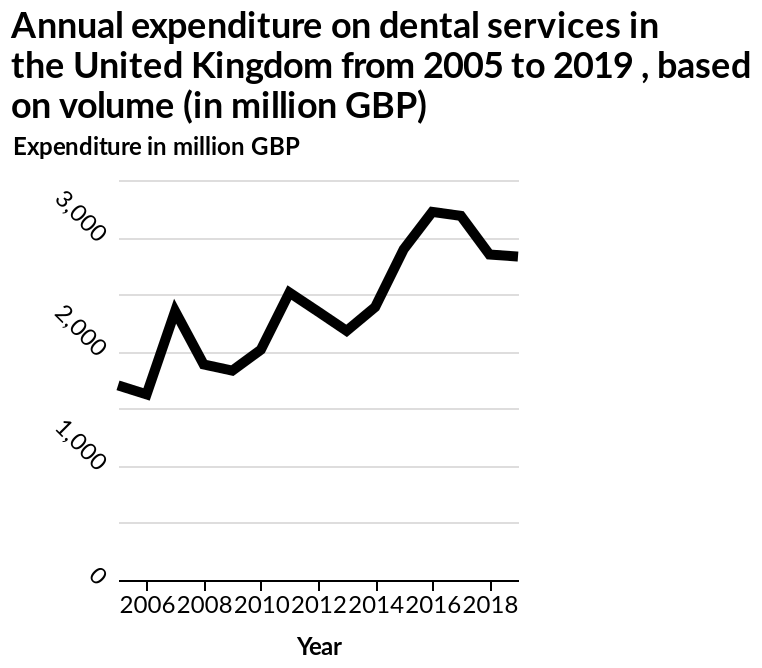<image>
Describe the following image in detail This is a line diagram called Annual expenditure on dental services in the United Kingdom from 2005 to 2019 , based on volume (in million GBP). The y-axis plots Expenditure in million GBP along linear scale from 0 to 3,500 while the x-axis plots Year with linear scale of range 2006 to 2018. What was the lowest expenditure in million GBP?  The lowest expenditure was in 2007 at 1,600 million GBP. Are there any peaks and falls in expenditure over the years? Yes, there are peaks and falls in expenditure on various years. Offer a thorough analysis of the image. Expenditure on dental services, in the UK, was at its highest around 2015, about £3,250. Since then expenditure has declined to around £2,750, in 2019. 